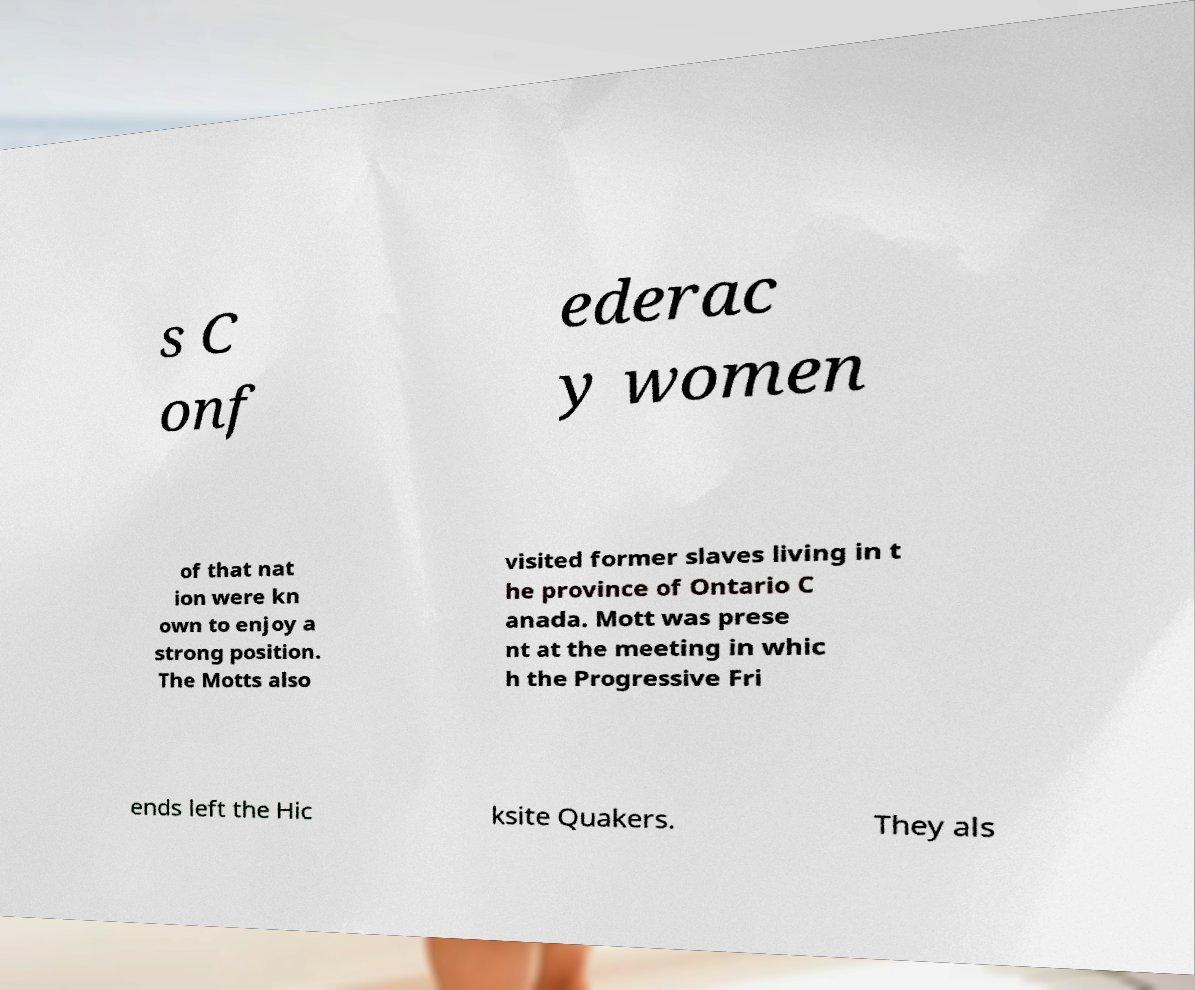Could you extract and type out the text from this image? s C onf ederac y women of that nat ion were kn own to enjoy a strong position. The Motts also visited former slaves living in t he province of Ontario C anada. Mott was prese nt at the meeting in whic h the Progressive Fri ends left the Hic ksite Quakers. They als 